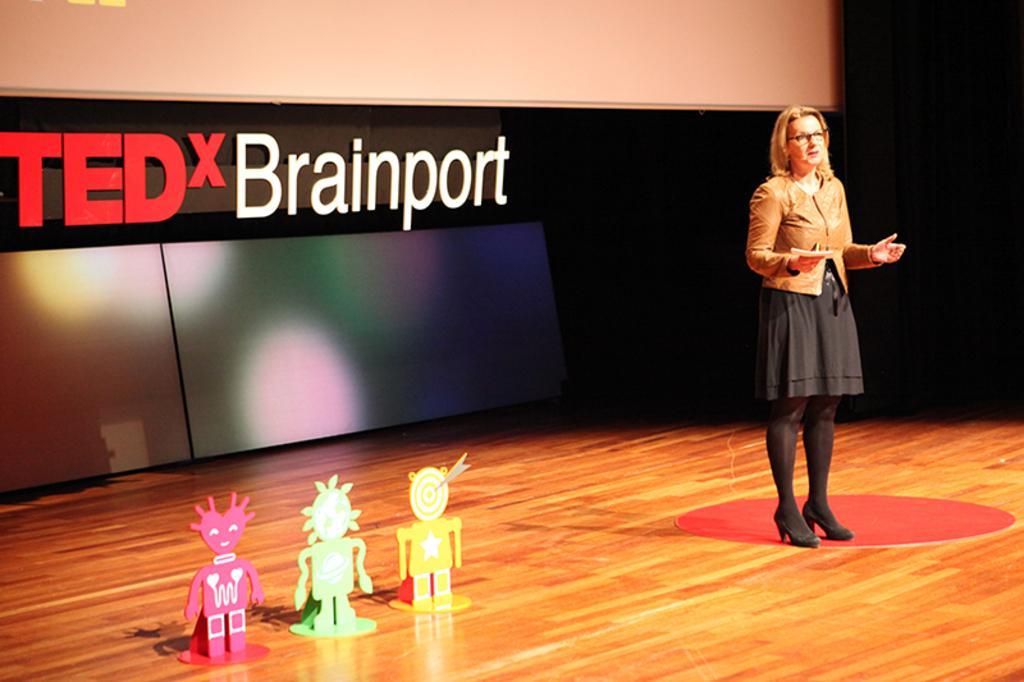Describe this image in one or two sentences. In the image we can see there is a woman standing and she is wearing a jacket. Beside there are 3 toys which are kept on the stage and behind there is a banner. 